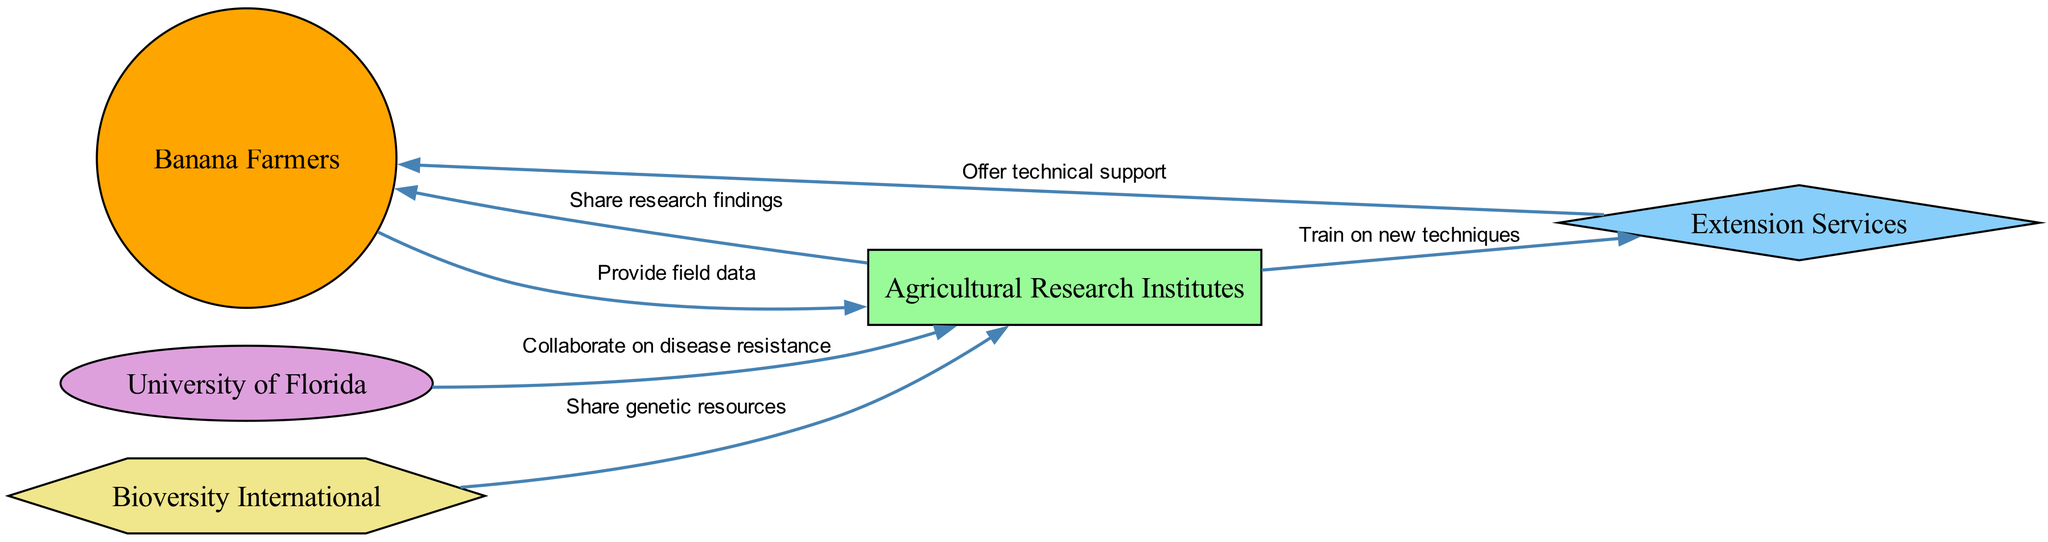What is the label for node 1? According to the diagram data, node 1 is labeled as "Banana Farmers."
Answer: Banana Farmers How many nodes are in the diagram? The diagram lists a total of five nodes, which are Banana Farmers, Agricultural Research Institutes, Extension Services, University of Florida, and Bioversity International.
Answer: 5 What relationship exists between Agricultural Research Institutes and Banana Farmers? The diagram indicates a two-way relationship; Agricultural Research Institutes share research findings with Banana Farmers and vice versa they provide field data to Agricultural Research Institutes.
Answer: Provide field data / Share research findings Which institution collaborates on disease resistance? The diagram specifies that the University of Florida collaborates with Agricultural Research Institutes on disease resistance.
Answer: University of Florida How many edges connect Agricultural Research Institutes and Extension Services? There is one edge connecting Agricultural Research Institutes to Extension Services, labeled "Train on new techniques."
Answer: 1 What type of relationship do Extension Services have with Banana Farmers? Extension Services offer technical support to Banana Farmers as indicated by the directed edge labeled "Offer technical support."
Answer: Offer technical support Which node shares genetic resources? The diagram specifies that Bioversity International shares genetic resources with Agricultural Research Institutes.
Answer: Bioversity International Which node is represented by a diamond shape? In the diagram, the node with the label "Extension Services" is represented by a diamond shape.
Answer: Extension Services What is the overall directionality of the relationships in this network diagram? The relationships in the diagram are mostly directed, indicating the flow of information and support among the participating nodes, although some relationships are bidirectional.
Answer: Directed What type of node is Agricultural Research Institutes? In the diagram, the Agricultural Research Institutes node is represented as a box shape.
Answer: Box 